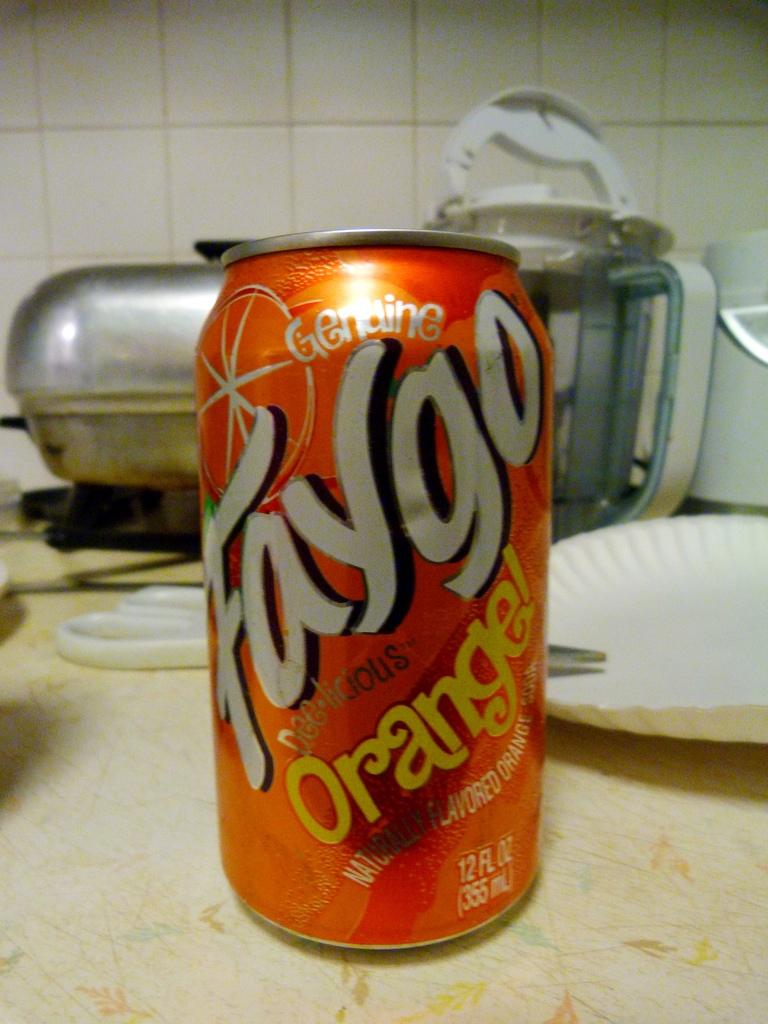How many fl oz?
Provide a short and direct response. 12. 